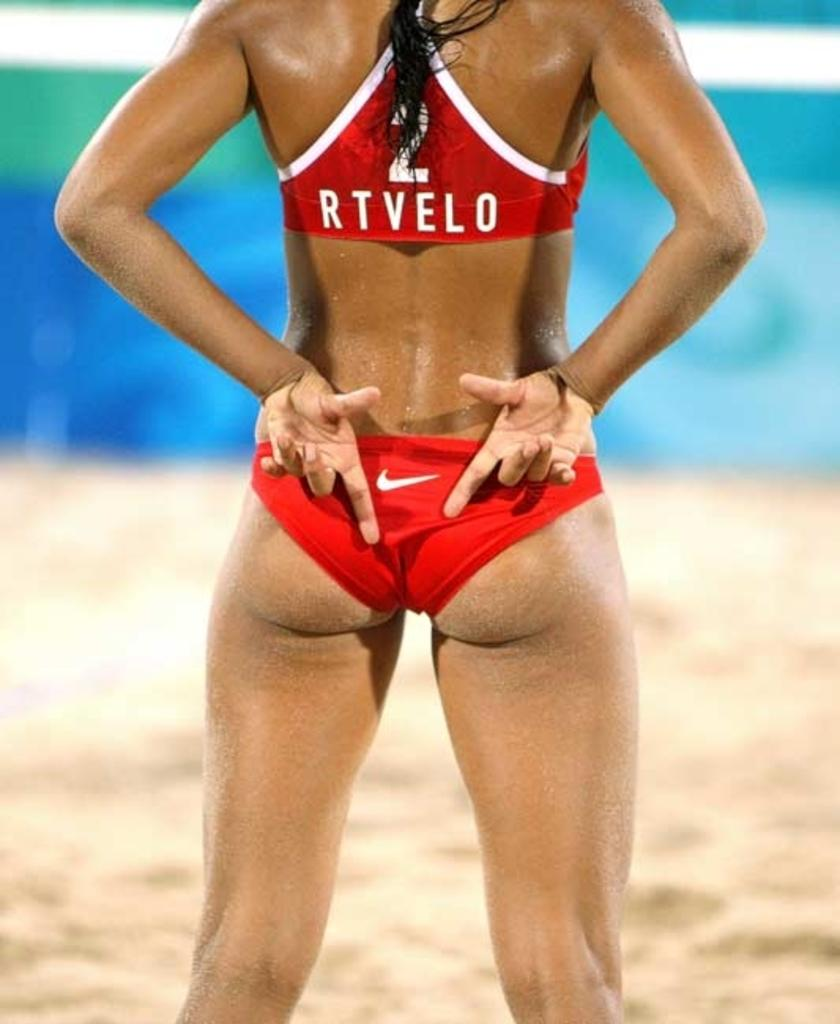<image>
Offer a succinct explanation of the picture presented. The woman beach volleyball plays has the name Rtvelo on her back. 